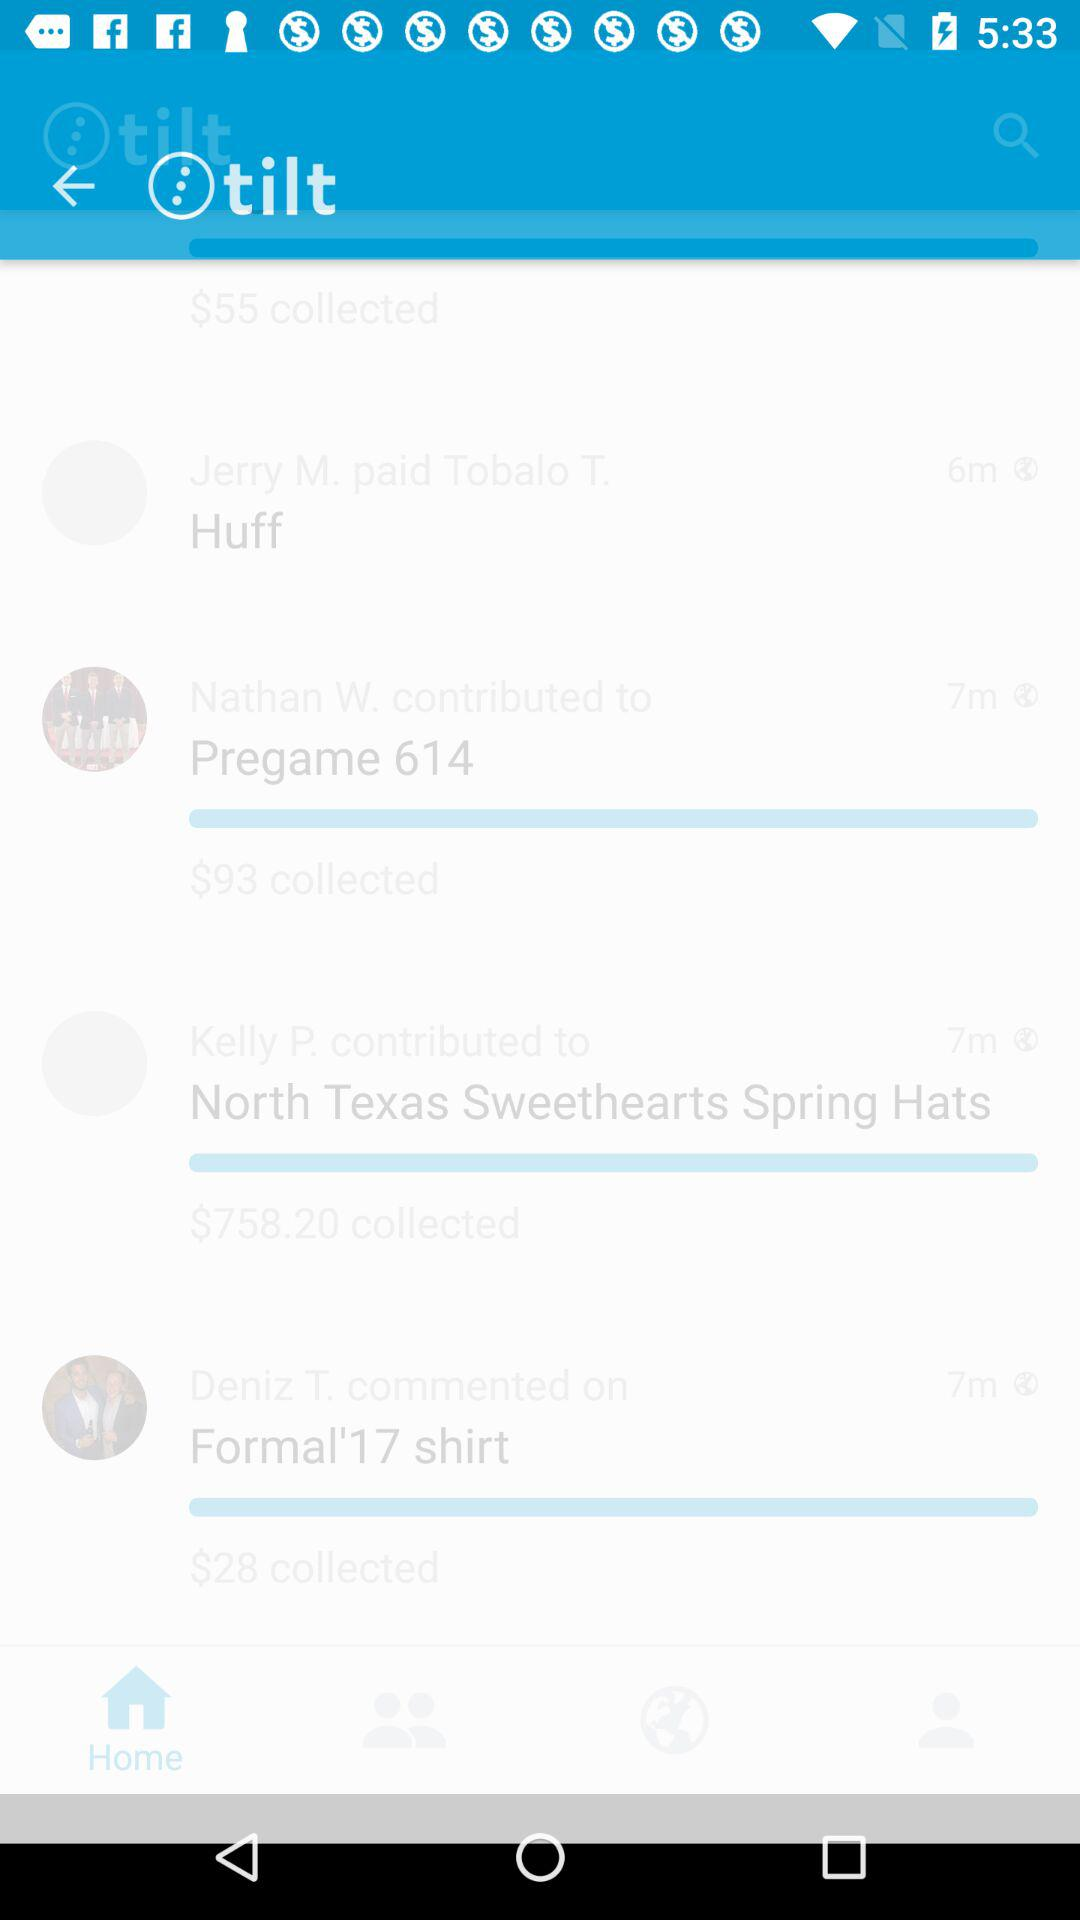Which event has the most amount of money collected?
Answer the question using a single word or phrase. North Texas Sweethearts Spring Hats 